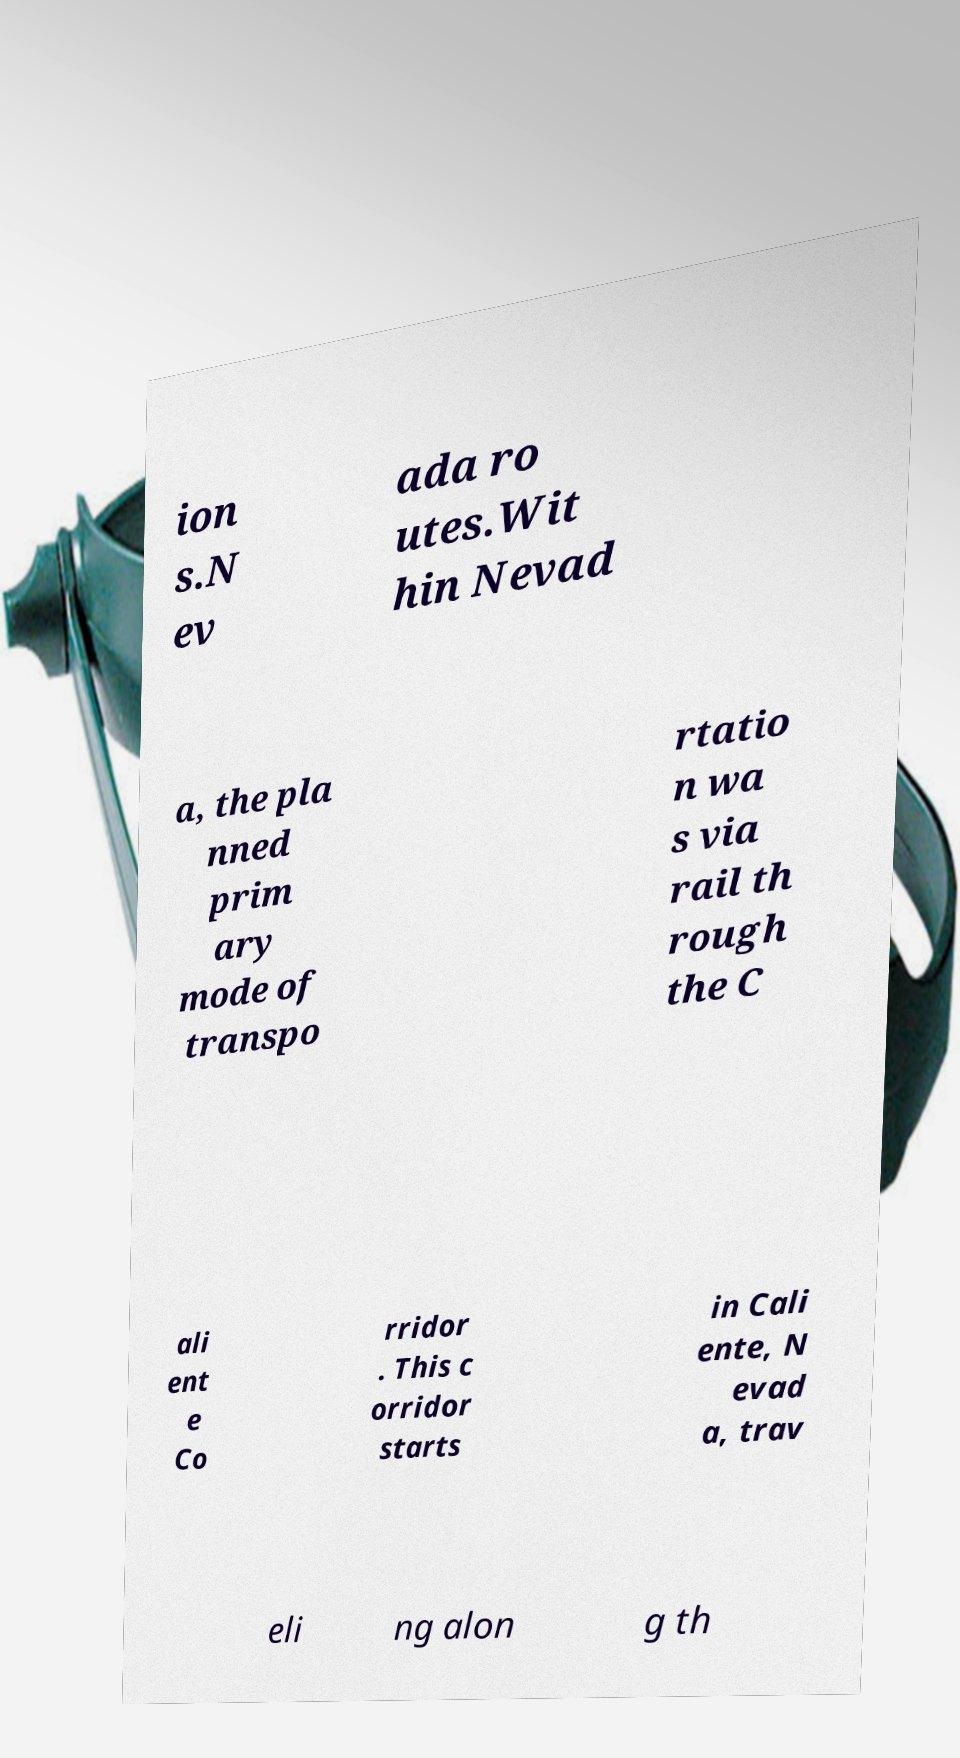Could you extract and type out the text from this image? ion s.N ev ada ro utes.Wit hin Nevad a, the pla nned prim ary mode of transpo rtatio n wa s via rail th rough the C ali ent e Co rridor . This c orridor starts in Cali ente, N evad a, trav eli ng alon g th 